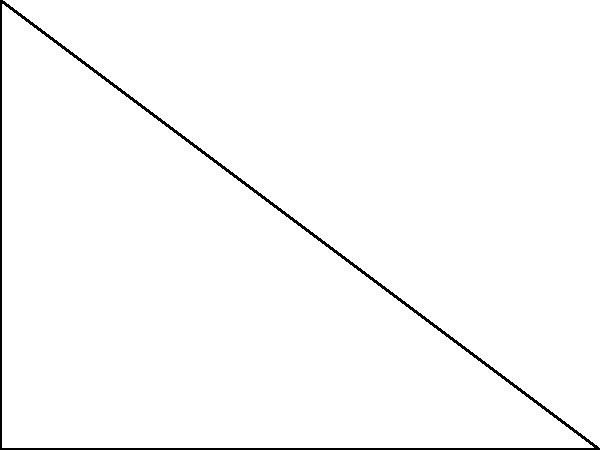In a right-angled triangle ABC, the length of the adjacent side (AB) is 4 units, and the length of the opposite side (BC) is 3 units. Calculate the length of the hypotenuse (AC) to the nearest tenth of a unit. To solve this problem, we'll use the Pythagorean theorem:

1) The Pythagorean theorem states that in a right-angled triangle, $a^2 + b^2 = c^2$, where $c$ is the length of the hypotenuse.

2) We know:
   Adjacent side (AB) = 4 units
   Opposite side (BC) = 3 units
   Let the hypotenuse (AC) = $x$ units

3) Applying the Pythagorean theorem:
   $4^2 + 3^2 = x^2$

4) Simplify:
   $16 + 9 = x^2$
   $25 = x^2$

5) Take the square root of both sides:
   $\sqrt{25} = x$
   $5 = x$

6) Therefore, the length of the hypotenuse is 5 units.

Since the question asks for the answer to the nearest tenth, and 5 is already expressed to the nearest tenth, our final answer is 5.0 units.
Answer: 5.0 units 